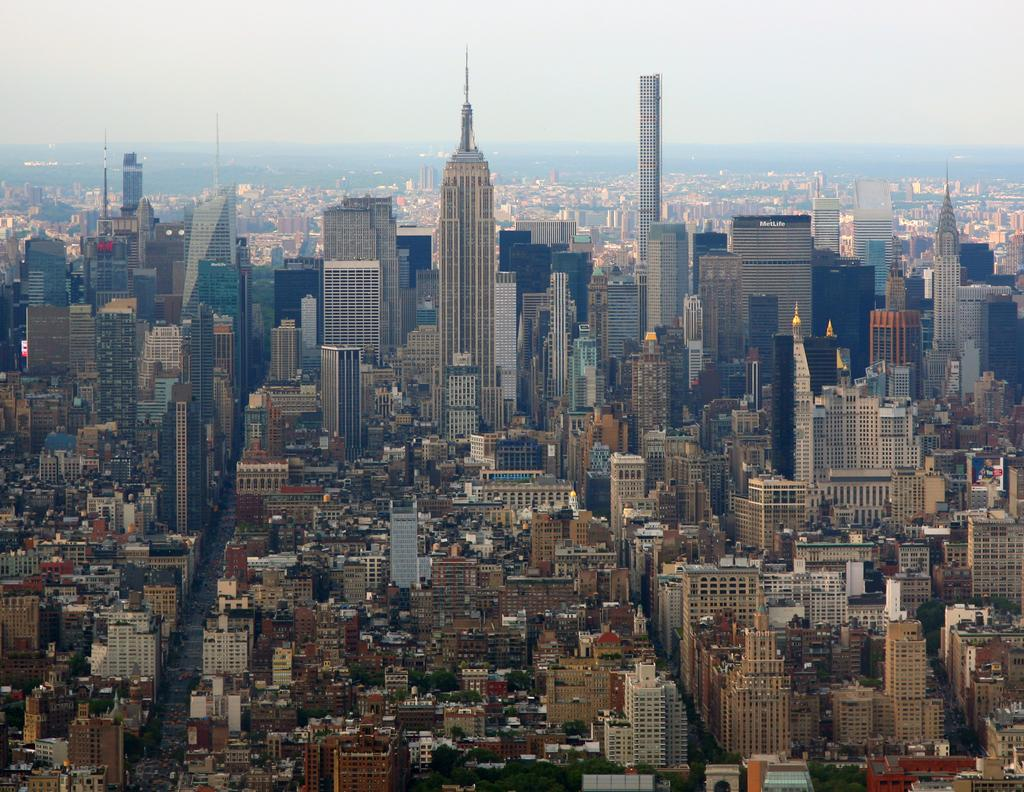What type of structures can be seen in the image? There are buildings in the image. What type of vegetation is present at the bottom of the image? There are trees at the bottom of the image. Where is the map located in the image? There is no map present in the image. What type of furniture is used for the crib in the image? There is no crib present in the image. 